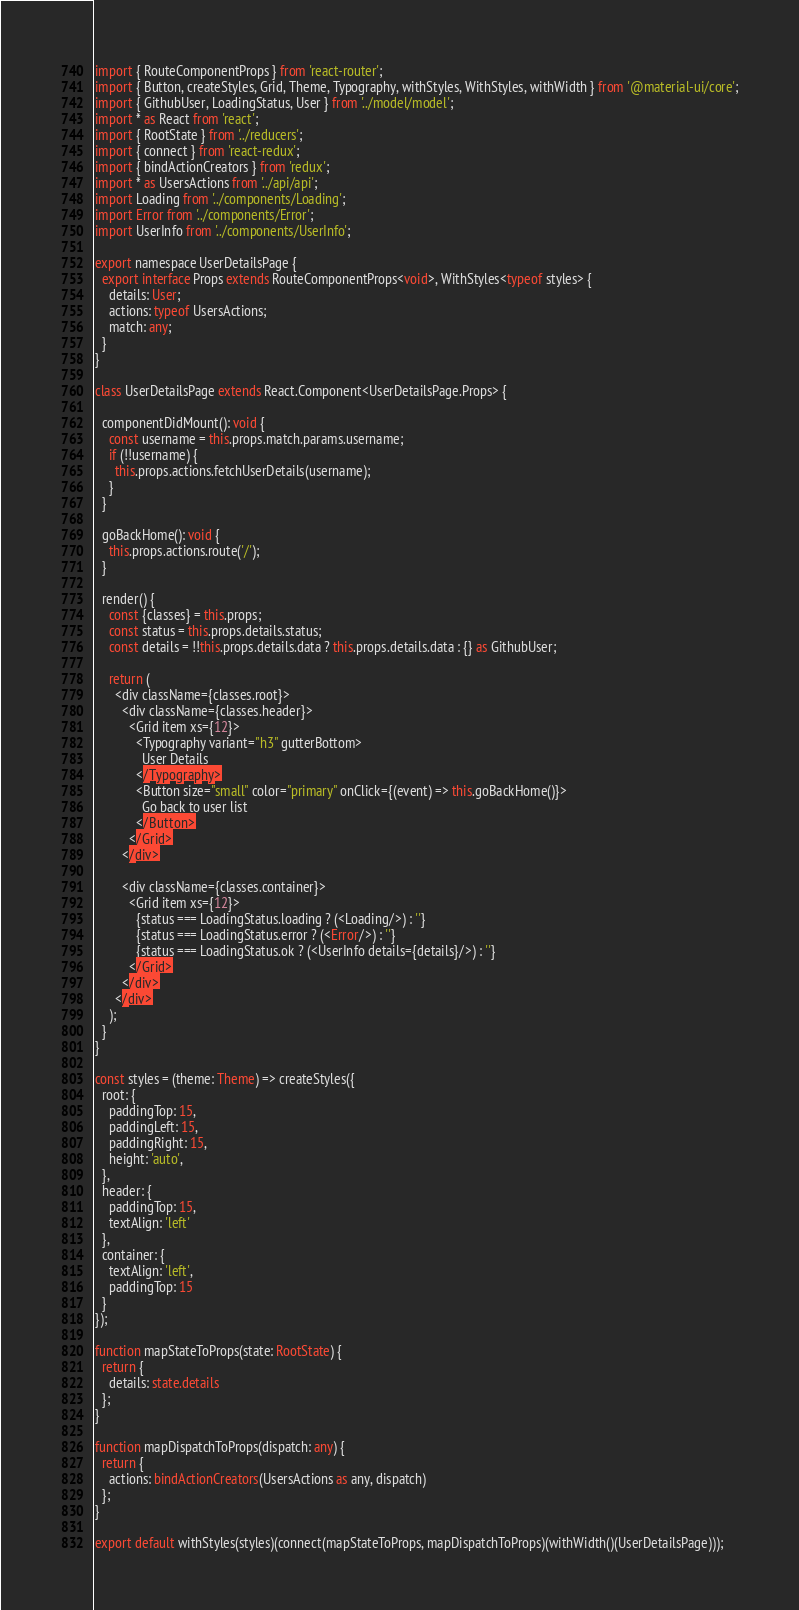Convert code to text. <code><loc_0><loc_0><loc_500><loc_500><_TypeScript_>import { RouteComponentProps } from 'react-router';
import { Button, createStyles, Grid, Theme, Typography, withStyles, WithStyles, withWidth } from '@material-ui/core';
import { GithubUser, LoadingStatus, User } from '../model/model';
import * as React from 'react';
import { RootState } from '../reducers';
import { connect } from 'react-redux';
import { bindActionCreators } from 'redux';
import * as UsersActions from '../api/api';
import Loading from '../components/Loading';
import Error from '../components/Error';
import UserInfo from '../components/UserInfo';

export namespace UserDetailsPage {
  export interface Props extends RouteComponentProps<void>, WithStyles<typeof styles> {
    details: User;
    actions: typeof UsersActions;
    match: any;
  }
}

class UserDetailsPage extends React.Component<UserDetailsPage.Props> {

  componentDidMount(): void {
    const username = this.props.match.params.username;
    if (!!username) {
      this.props.actions.fetchUserDetails(username);
    }
  }

  goBackHome(): void {
    this.props.actions.route('/');
  }

  render() {
    const {classes} = this.props;
    const status = this.props.details.status;
    const details = !!this.props.details.data ? this.props.details.data : {} as GithubUser;

    return (
      <div className={classes.root}>
        <div className={classes.header}>
          <Grid item xs={12}>
            <Typography variant="h3" gutterBottom>
              User Details
            </Typography>
            <Button size="small" color="primary" onClick={(event) => this.goBackHome()}>
              Go back to user list
            </Button>
          </Grid>
        </div>

        <div className={classes.container}>
          <Grid item xs={12}>
            {status === LoadingStatus.loading ? (<Loading/>) : ''}
            {status === LoadingStatus.error ? (<Error/>) : ''}
            {status === LoadingStatus.ok ? (<UserInfo details={details}/>) : ''}
          </Grid>
        </div>
      </div>
    );
  }
}

const styles = (theme: Theme) => createStyles({
  root: {
    paddingTop: 15,
    paddingLeft: 15,
    paddingRight: 15,
    height: 'auto',
  },
  header: {
    paddingTop: 15,
    textAlign: 'left'
  },
  container: {
    textAlign: 'left',
    paddingTop: 15
  }
});

function mapStateToProps(state: RootState) {
  return {
    details: state.details
  };
}

function mapDispatchToProps(dispatch: any) {
  return {
    actions: bindActionCreators(UsersActions as any, dispatch)
  };
}

export default withStyles(styles)(connect(mapStateToProps, mapDispatchToProps)(withWidth()(UserDetailsPage)));
</code> 